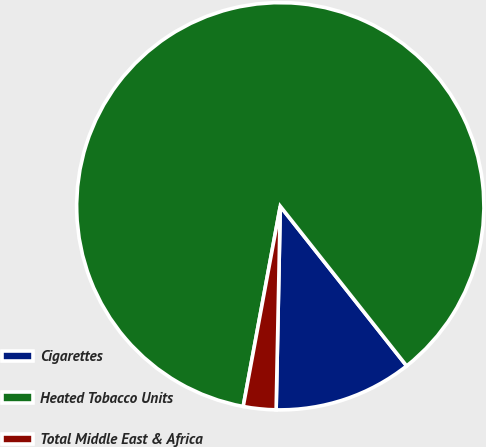Convert chart to OTSL. <chart><loc_0><loc_0><loc_500><loc_500><pie_chart><fcel>Cigarettes<fcel>Heated Tobacco Units<fcel>Total Middle East & Africa<nl><fcel>10.98%<fcel>86.43%<fcel>2.59%<nl></chart> 